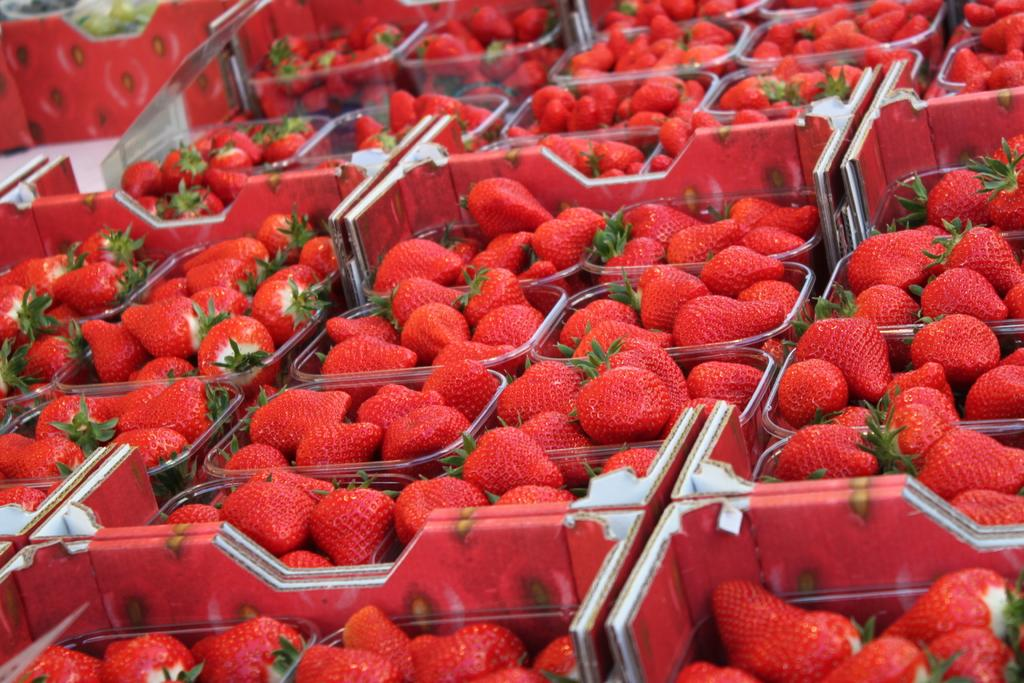What type of fruit is predominantly featured in the image? There are many strawberries in the image. How are the strawberries stored in the image? The strawberries are kept in plastic boxes. What other fruits can be seen in the image? There are fruits in the top left corner of the image. How are these other fruits stored? The fruits are kept on a cotton box. What type of flower is placed on top of the cake in the image? There is no cake or flower present in the image; it features strawberries and other fruits stored in boxes. 